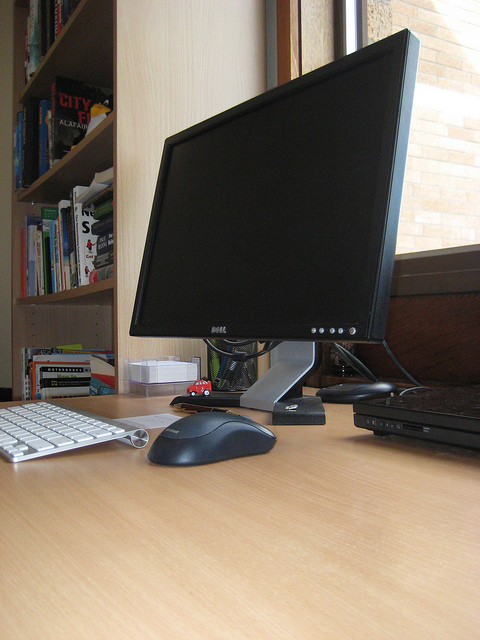Identify and read out the text in this image. CITY 